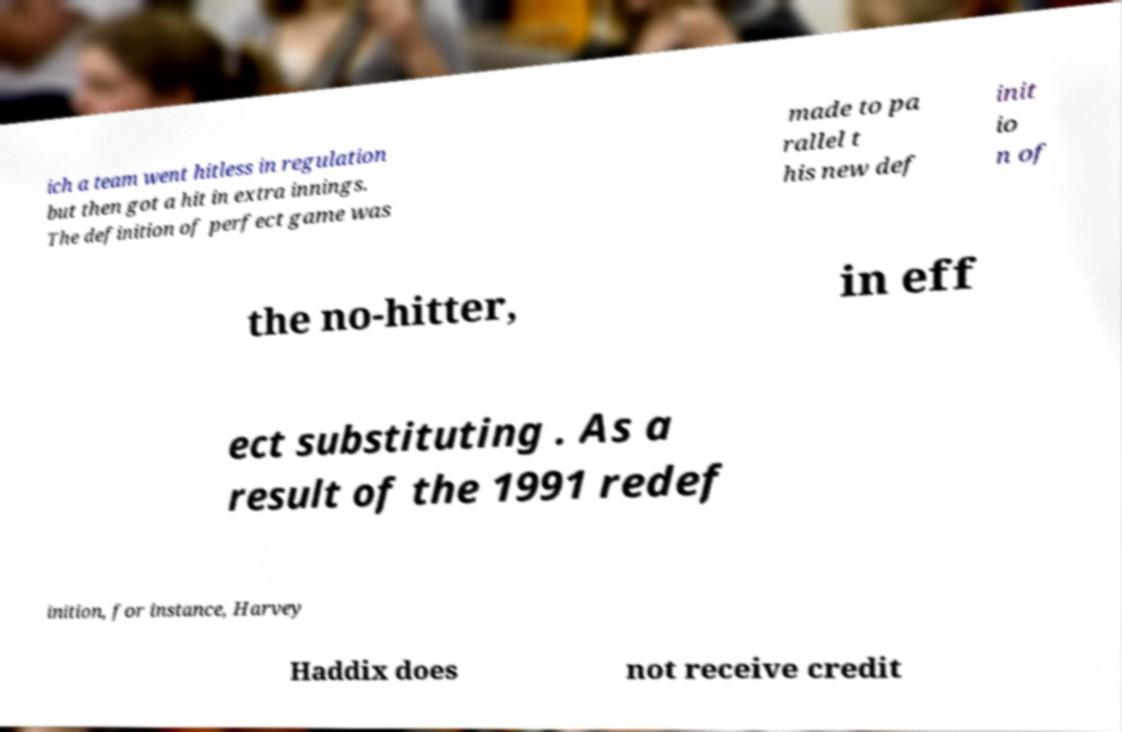Can you read and provide the text displayed in the image?This photo seems to have some interesting text. Can you extract and type it out for me? ich a team went hitless in regulation but then got a hit in extra innings. The definition of perfect game was made to pa rallel t his new def init io n of the no-hitter, in eff ect substituting . As a result of the 1991 redef inition, for instance, Harvey Haddix does not receive credit 